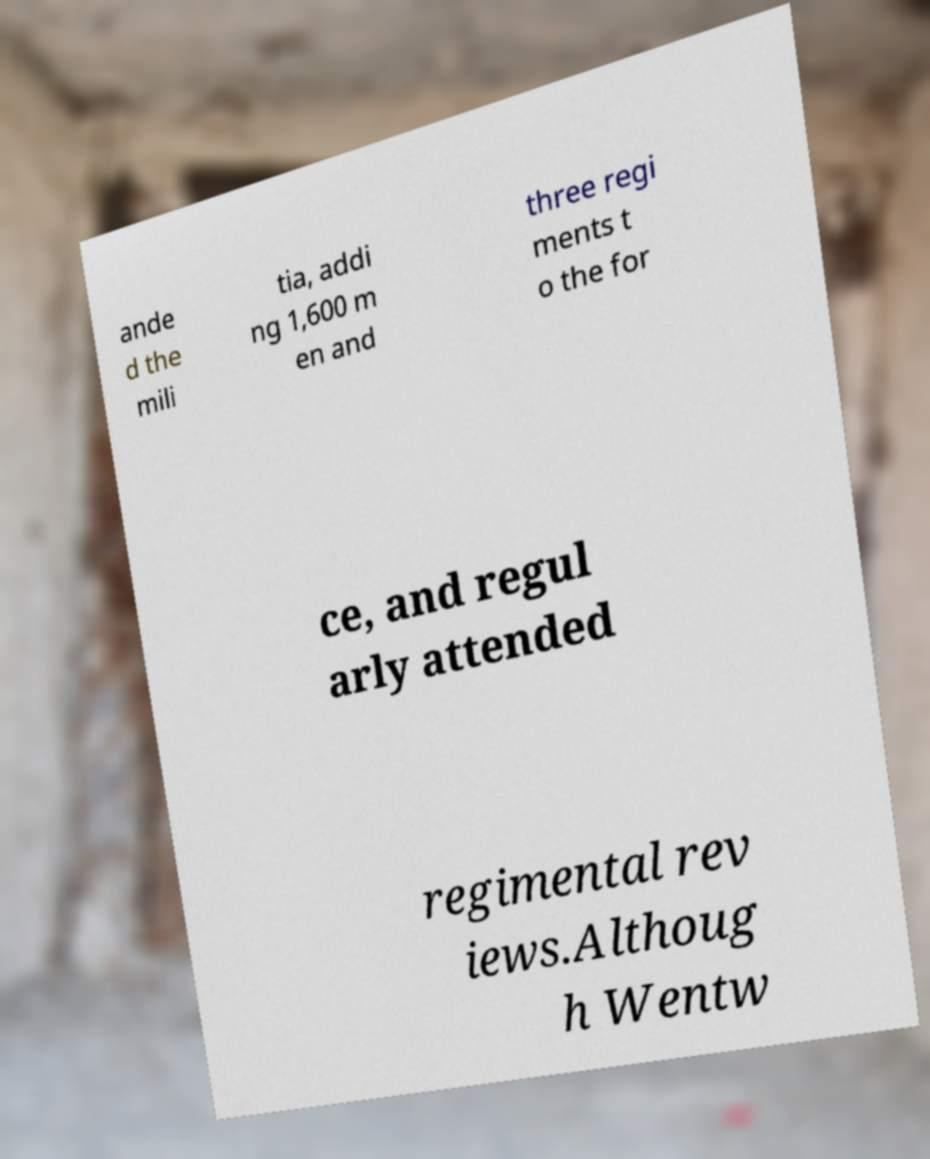Could you extract and type out the text from this image? ande d the mili tia, addi ng 1,600 m en and three regi ments t o the for ce, and regul arly attended regimental rev iews.Althoug h Wentw 